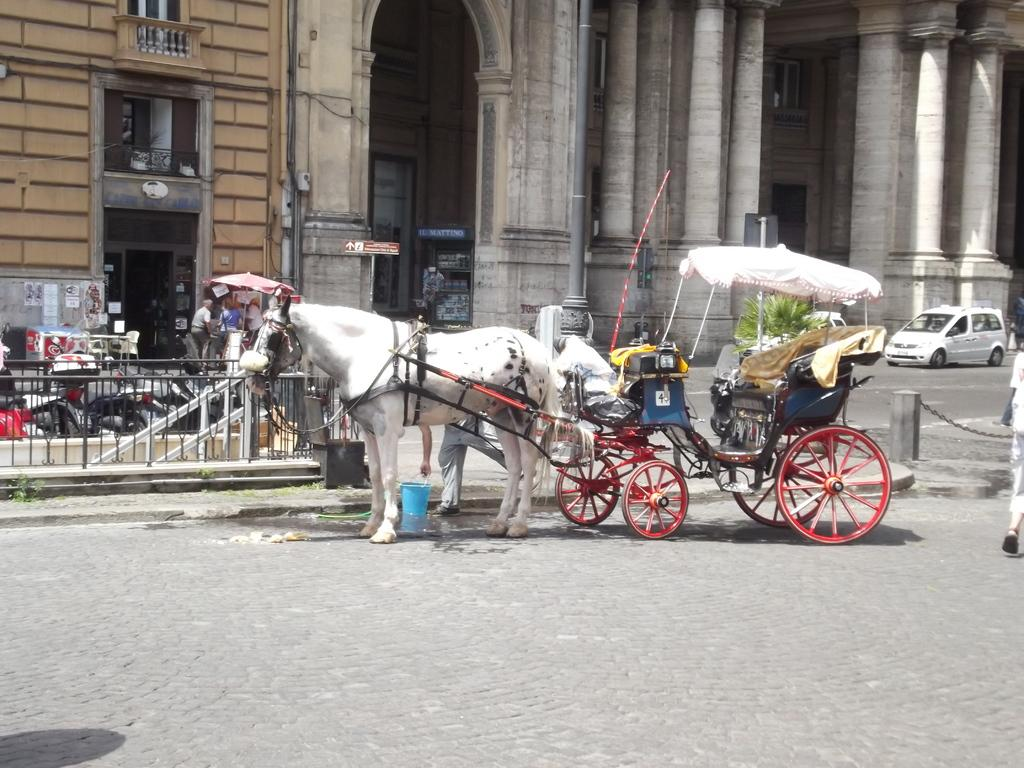What mode of transportation can be seen on the road in the image? There is a horse cart on the road in the image. What is located behind the horse cart? There is a building behind the horse cart. What else can be seen near the building? Vehicles and people are visible near the building. Can you see any bears or mice near the horse cart in the image? No, there are no bears or mice present in the image. 